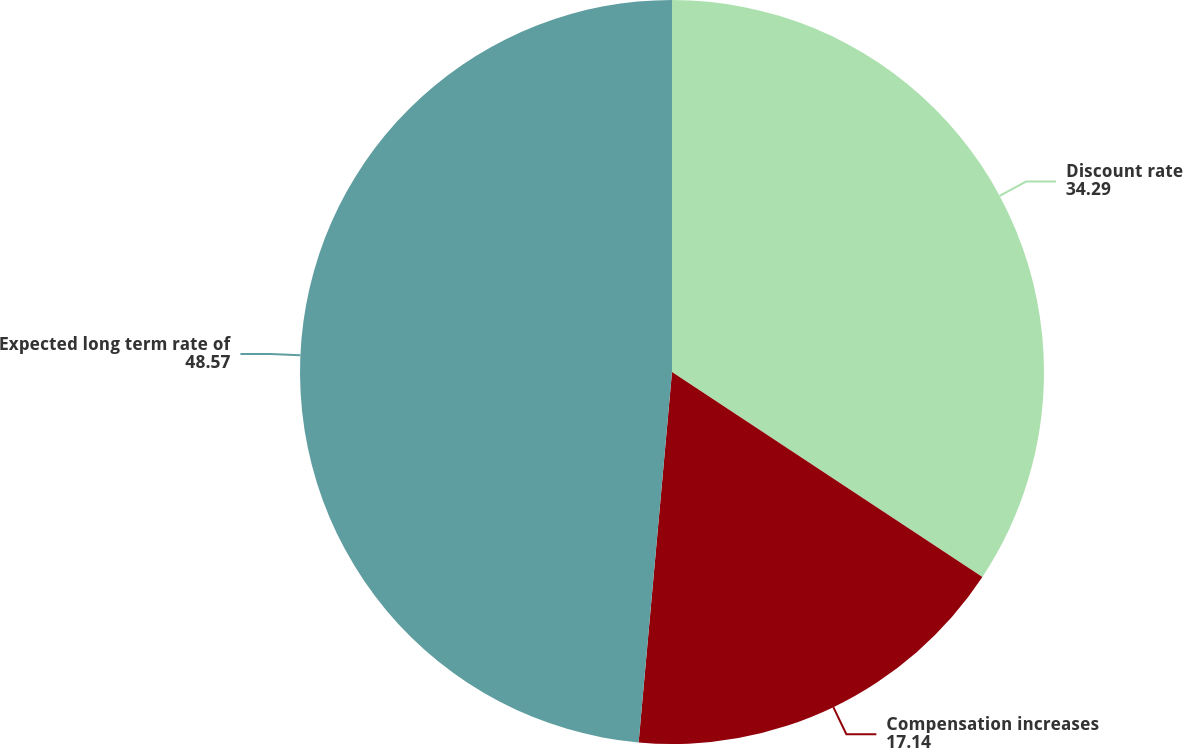Convert chart. <chart><loc_0><loc_0><loc_500><loc_500><pie_chart><fcel>Discount rate<fcel>Compensation increases<fcel>Expected long term rate of<nl><fcel>34.29%<fcel>17.14%<fcel>48.57%<nl></chart> 